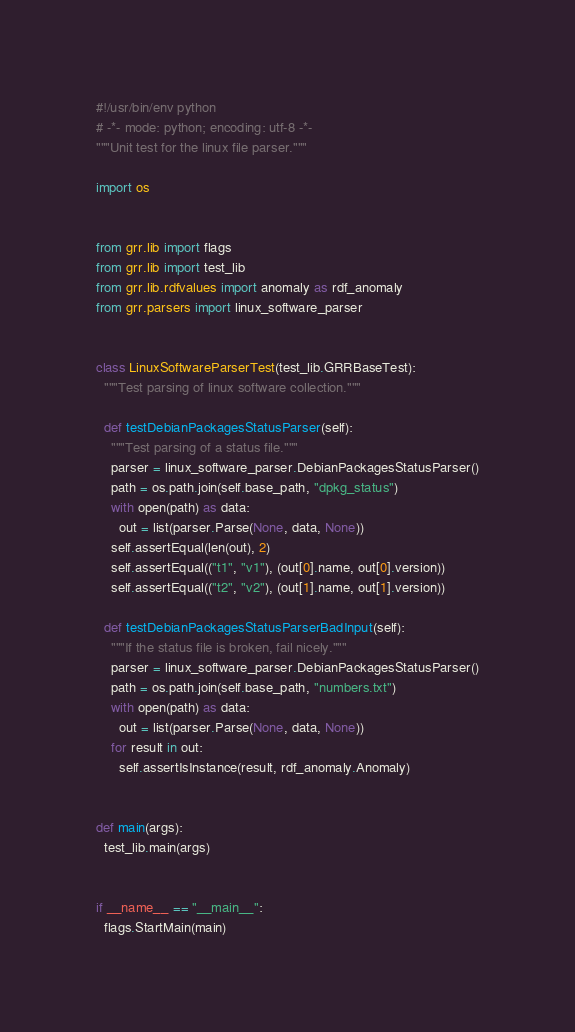Convert code to text. <code><loc_0><loc_0><loc_500><loc_500><_Python_>#!/usr/bin/env python
# -*- mode: python; encoding: utf-8 -*-
"""Unit test for the linux file parser."""

import os


from grr.lib import flags
from grr.lib import test_lib
from grr.lib.rdfvalues import anomaly as rdf_anomaly
from grr.parsers import linux_software_parser


class LinuxSoftwareParserTest(test_lib.GRRBaseTest):
  """Test parsing of linux software collection."""

  def testDebianPackagesStatusParser(self):
    """Test parsing of a status file."""
    parser = linux_software_parser.DebianPackagesStatusParser()
    path = os.path.join(self.base_path, "dpkg_status")
    with open(path) as data:
      out = list(parser.Parse(None, data, None))
    self.assertEqual(len(out), 2)
    self.assertEqual(("t1", "v1"), (out[0].name, out[0].version))
    self.assertEqual(("t2", "v2"), (out[1].name, out[1].version))

  def testDebianPackagesStatusParserBadInput(self):
    """If the status file is broken, fail nicely."""
    parser = linux_software_parser.DebianPackagesStatusParser()
    path = os.path.join(self.base_path, "numbers.txt")
    with open(path) as data:
      out = list(parser.Parse(None, data, None))
    for result in out:
      self.assertIsInstance(result, rdf_anomaly.Anomaly)


def main(args):
  test_lib.main(args)


if __name__ == "__main__":
  flags.StartMain(main)
</code> 